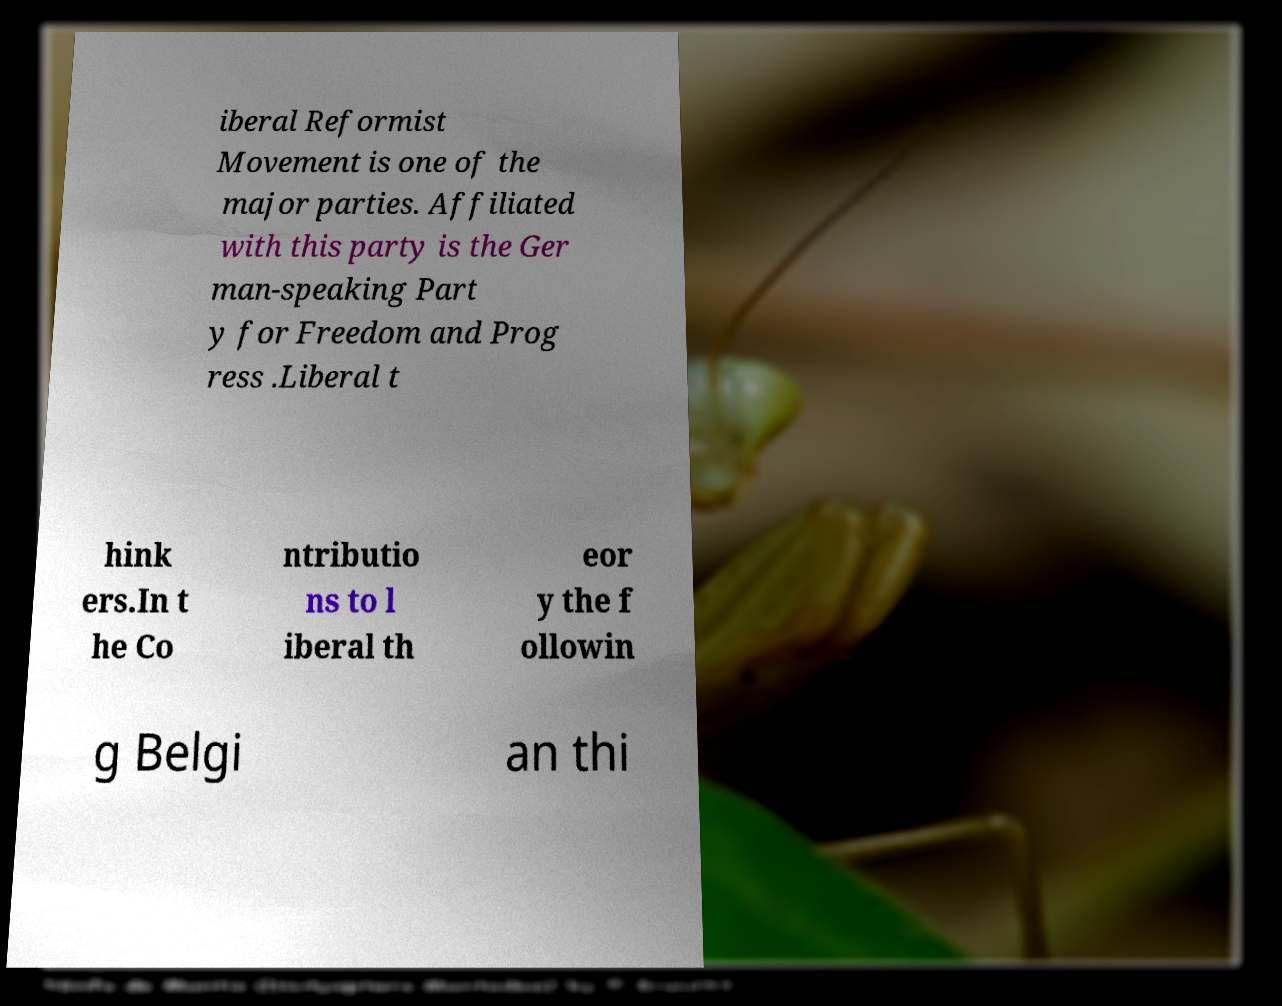I need the written content from this picture converted into text. Can you do that? iberal Reformist Movement is one of the major parties. Affiliated with this party is the Ger man-speaking Part y for Freedom and Prog ress .Liberal t hink ers.In t he Co ntributio ns to l iberal th eor y the f ollowin g Belgi an thi 